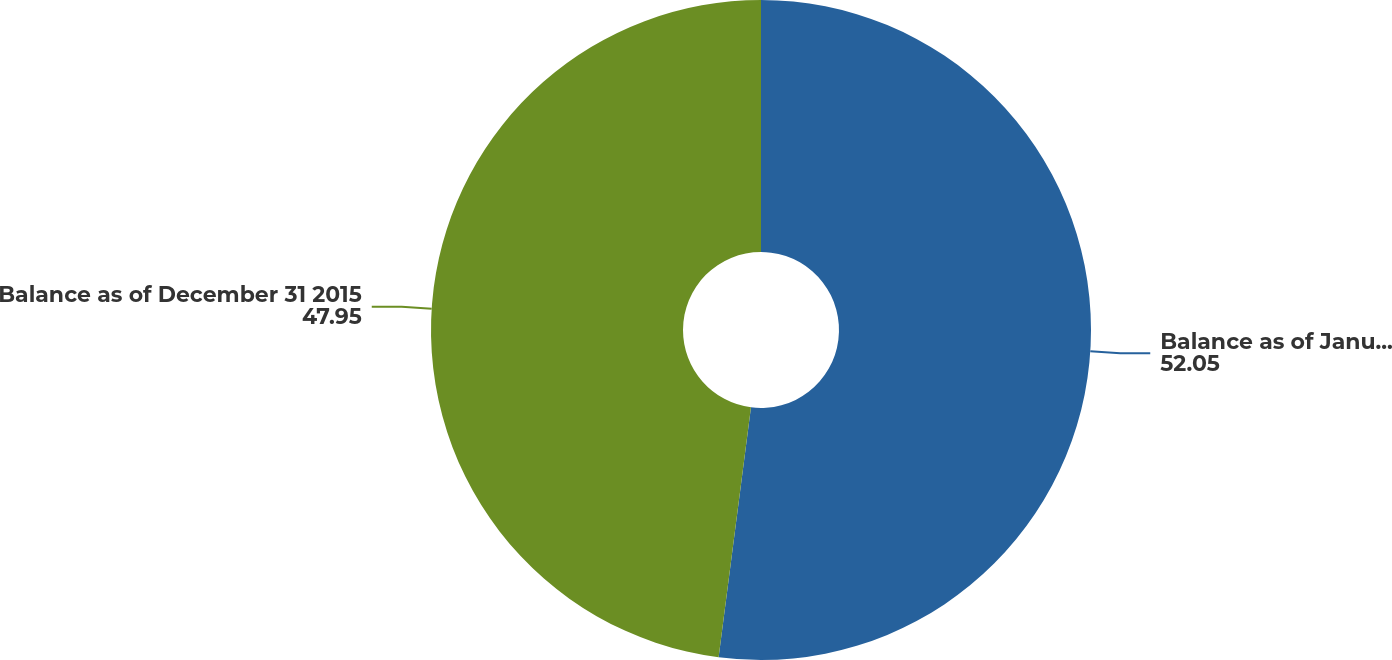Convert chart. <chart><loc_0><loc_0><loc_500><loc_500><pie_chart><fcel>Balance as of January 1 2015<fcel>Balance as of December 31 2015<nl><fcel>52.05%<fcel>47.95%<nl></chart> 